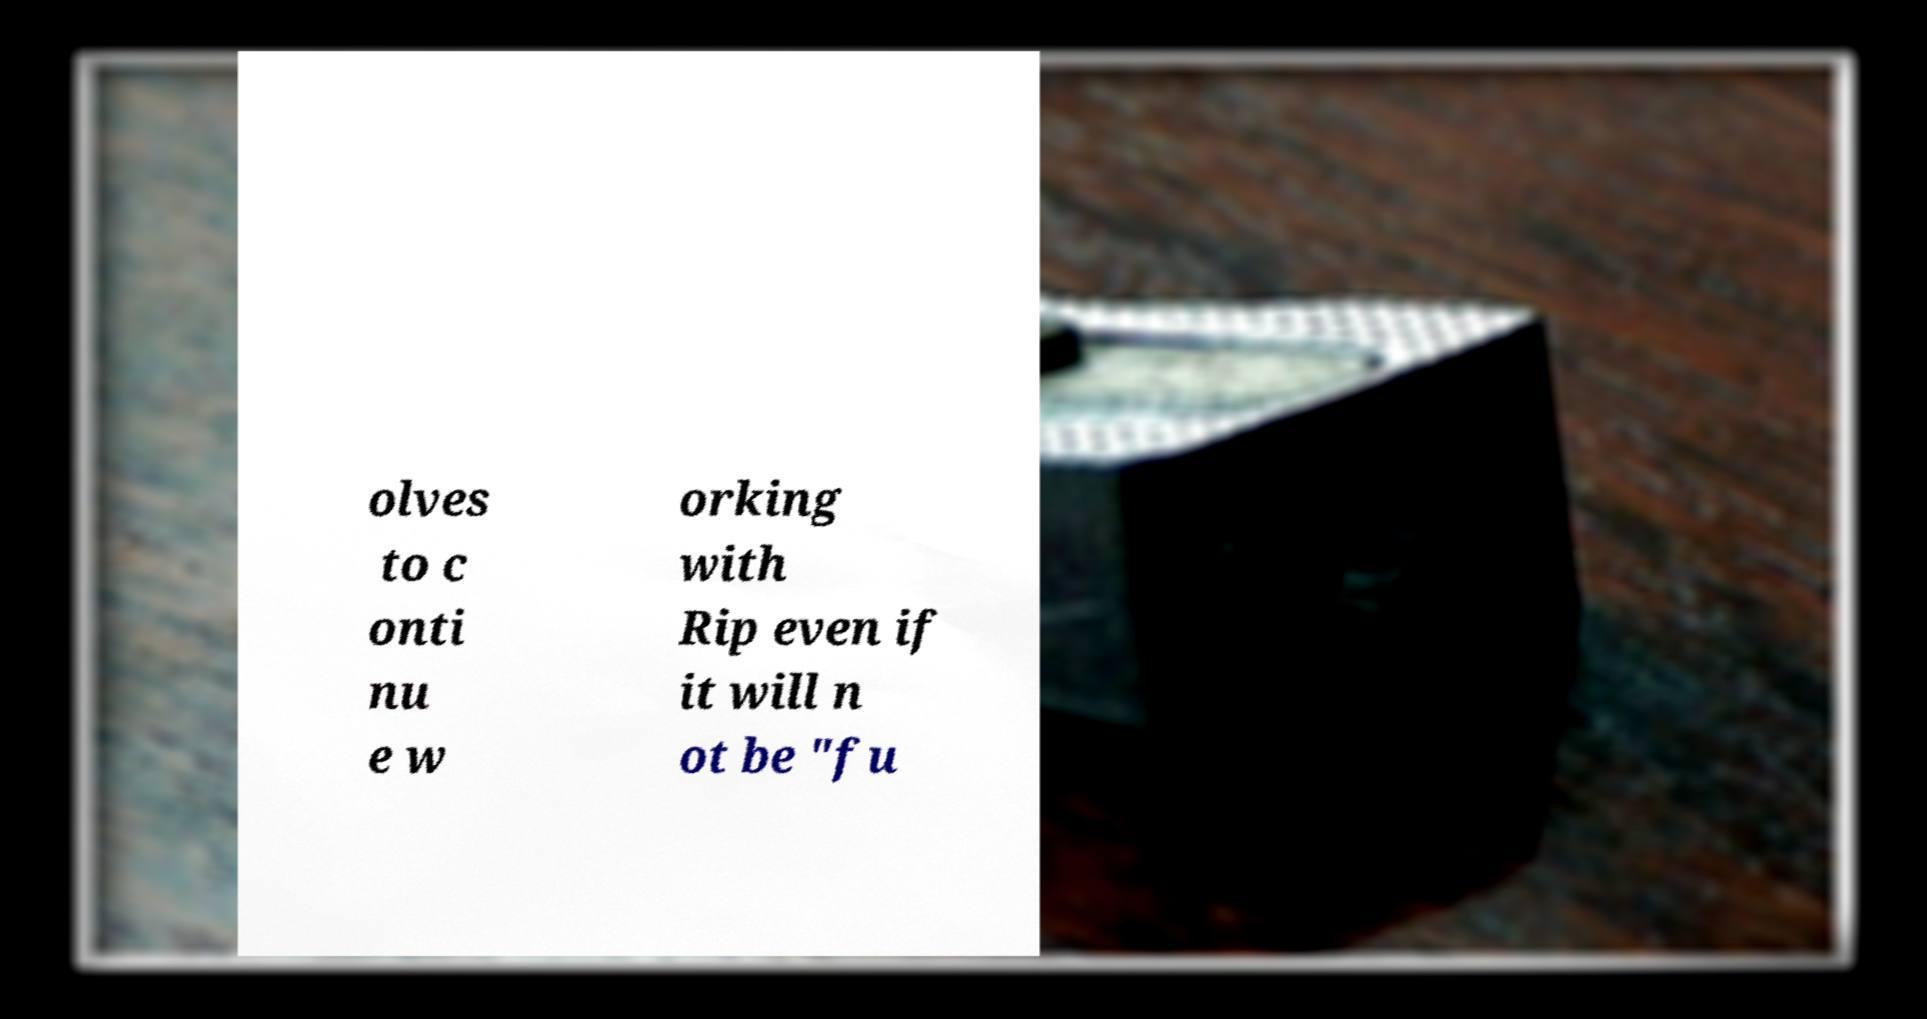Could you extract and type out the text from this image? olves to c onti nu e w orking with Rip even if it will n ot be "fu 